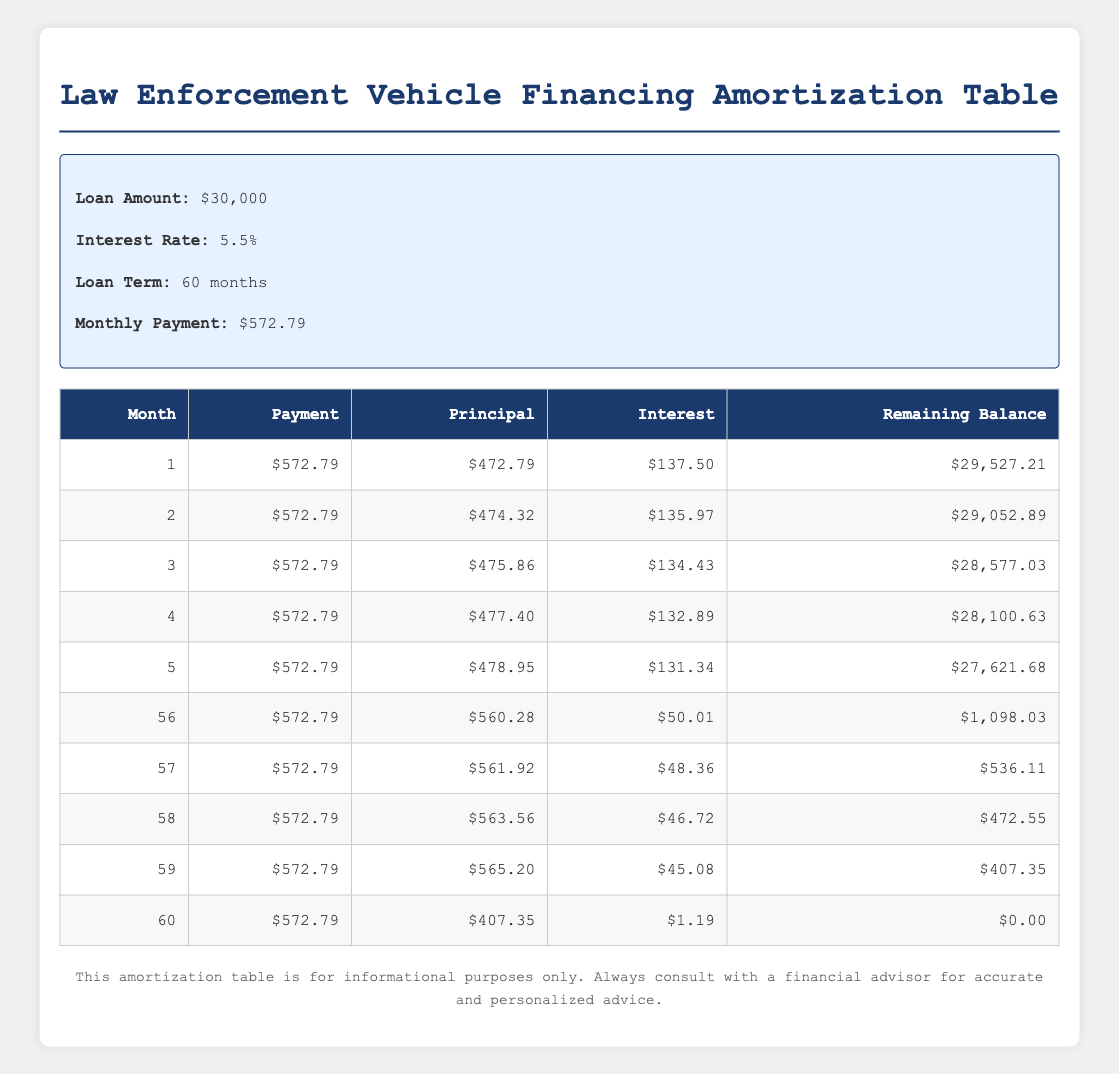What is the monthly payment for the vehicle financing? Referring to the information section of the table, the monthly payment is explicitly stated as $572.79.
Answer: $572.79 What is the total interest paid in the first month? In the first month, the interest paid is clearly indicated as $137.50.
Answer: $137.50 How much principal is paid off in the 10th month? By looking at the 10th row of the table, the principal paid off in that month is provided as $486.73.
Answer: $486.73 What is the remaining balance after 36 months? In the 36th month, the remaining balance is shown as $11,994.48.
Answer: $11,994.48 How much is the total of principal payments after 12 months? The principal payments for the first twelve months can be summed up from the table: $472.79 + $474.32 + $475.86 + $477.40 + $478.95 + $480.50 + $482.06 + $483.61 + $485.17 + $486.73 + $488.29 + $489.85 = $5,723.88.
Answer: $5,723.88 Is the interest paid in the last month more than $2? The interest paid in the last month (60th month) is noted as $1.19, which is less than $2.
Answer: No What is the average monthly payment over the loan term? The monthly payment remains constant at $572.79 over the loan term of 60 months. Therefore, the average is the same as the monthly payment: $572.79.
Answer: $572.79 How much total principal is paid off in the final three months? The total principal for the last three months is calculated as follows: $561.92 + $563.56 + $407.35 = $1,532.83.
Answer: $1,532.83 Does the principal paid in month 30 exceed the average principal paid over the first 30 months? The average principal paid over the first 30 months can be computed from the relevant data, which is ($472.79 + $474.32 + ... + $518.29) / 30 = $511.21 (approx). The principal for month 30 is $518.29, which exceeds the average.
Answer: Yes How does the remaining balance decrease from month 1 to month 12? The remaining balance after the first month is $29,527.21, and after the twelfth month, it is $24,225.47. Thus, the decrease is $29,527.21 - $24,225.47 = $5,301.74.
Answer: $5,301.74 